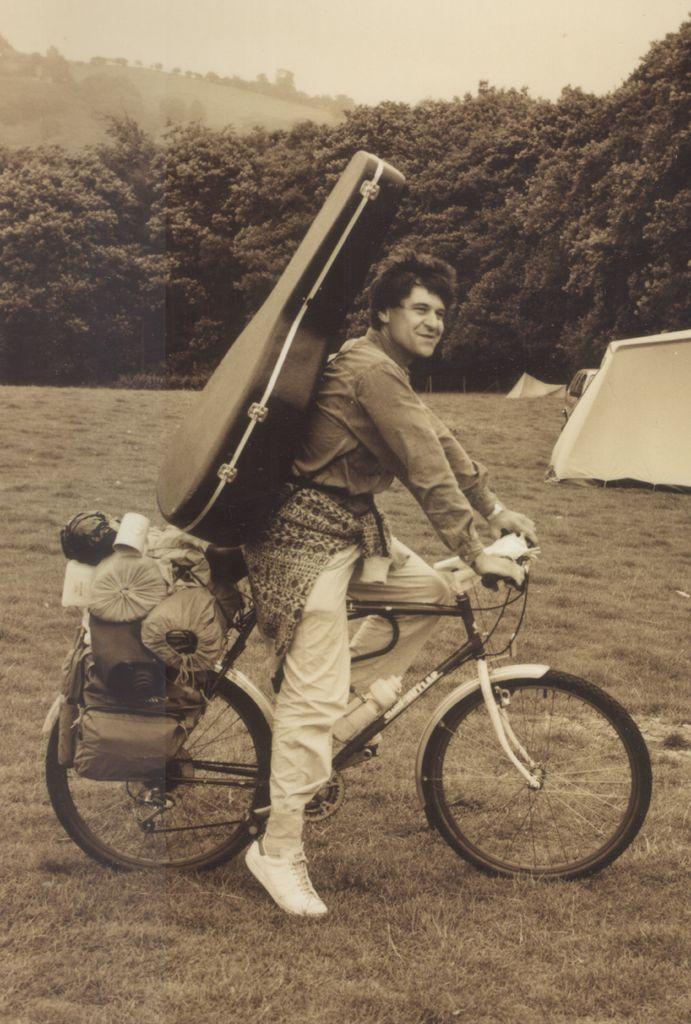Can you describe this image briefly? As we can see in the image there is a sky, trees, a man wearing guitar and holding bicycle. 